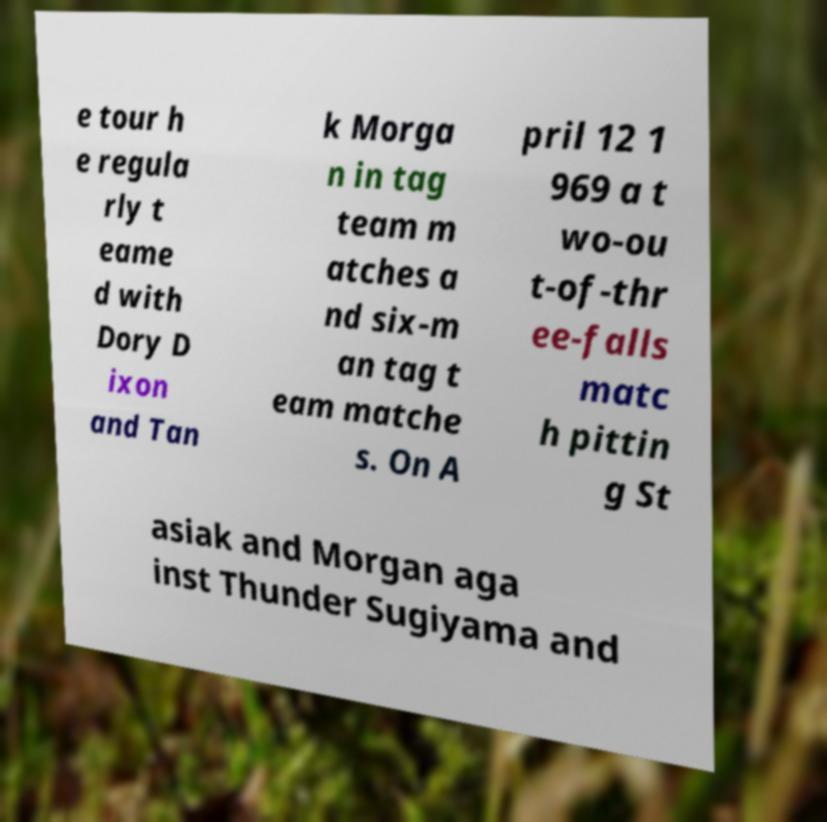Please identify and transcribe the text found in this image. e tour h e regula rly t eame d with Dory D ixon and Tan k Morga n in tag team m atches a nd six-m an tag t eam matche s. On A pril 12 1 969 a t wo-ou t-of-thr ee-falls matc h pittin g St asiak and Morgan aga inst Thunder Sugiyama and 